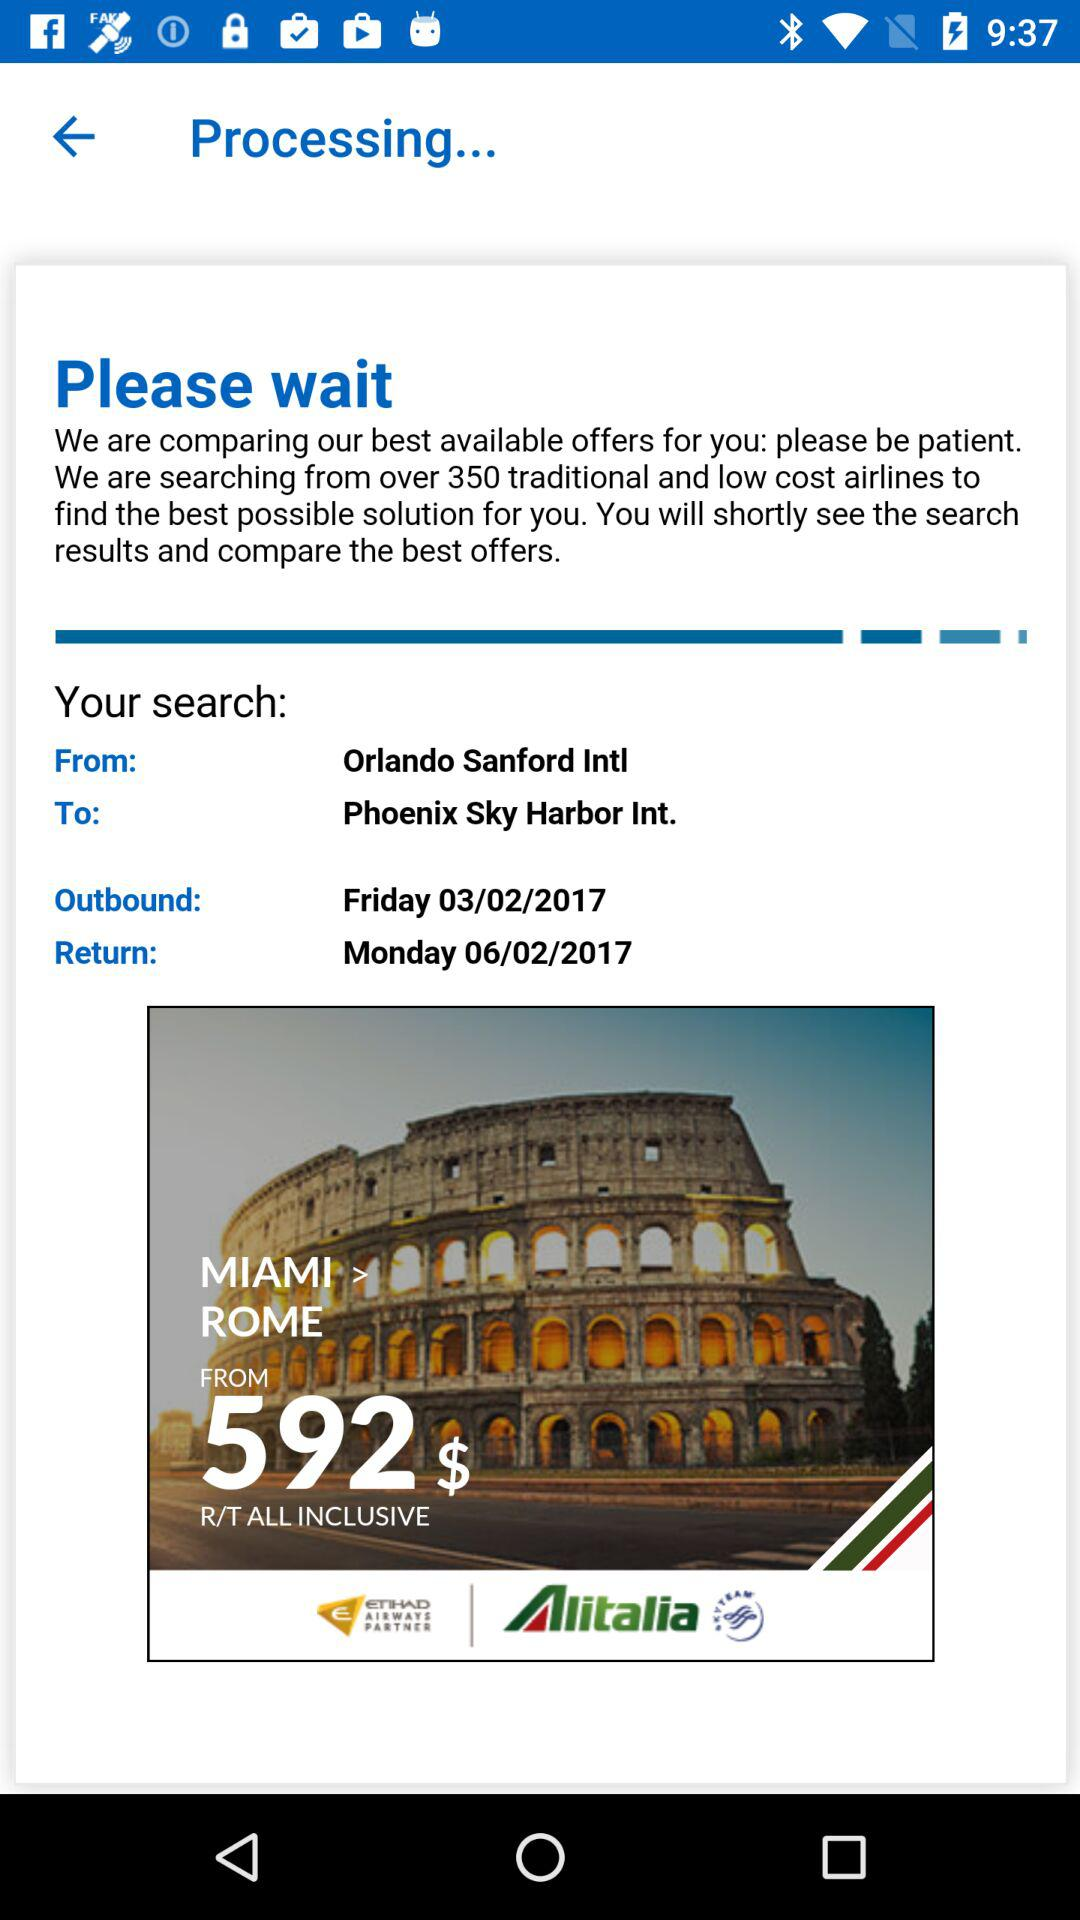When will the user return? The user will return on Monday, February 6, 2017. 